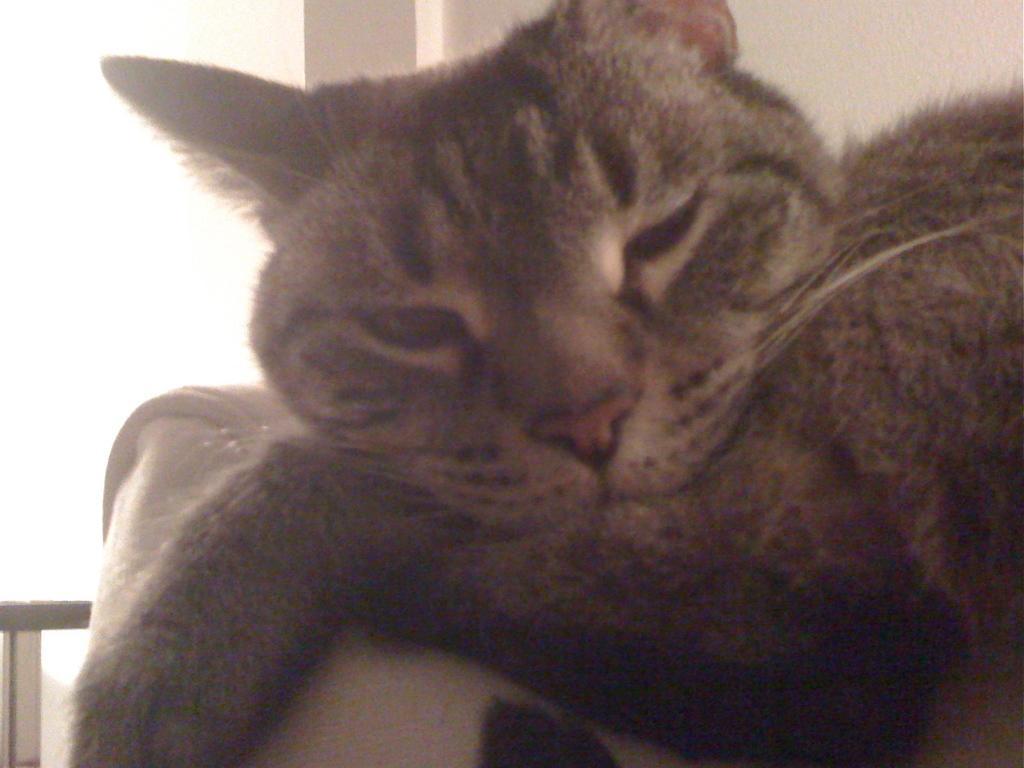Could you give a brief overview of what you see in this image? In this image I can see a cat and at the top I can see the wall. 